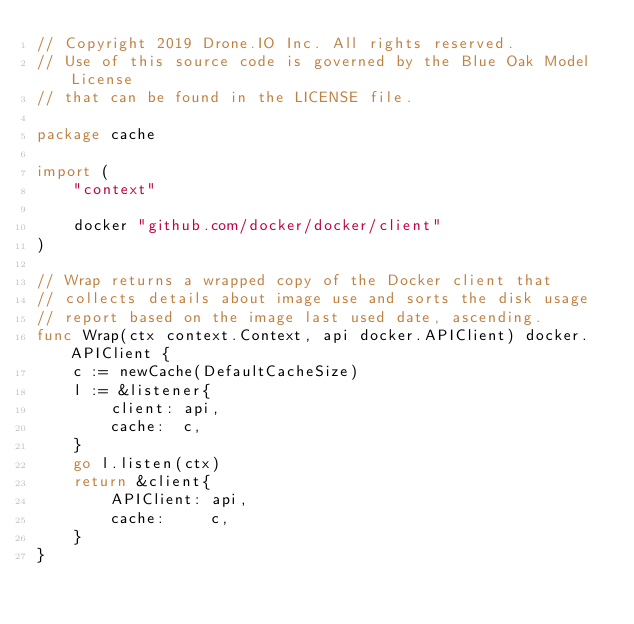Convert code to text. <code><loc_0><loc_0><loc_500><loc_500><_Go_>// Copyright 2019 Drone.IO Inc. All rights reserved.
// Use of this source code is governed by the Blue Oak Model License
// that can be found in the LICENSE file.

package cache

import (
	"context"

	docker "github.com/docker/docker/client"
)

// Wrap returns a wrapped copy of the Docker client that
// collects details about image use and sorts the disk usage
// report based on the image last used date, ascending.
func Wrap(ctx context.Context, api docker.APIClient) docker.APIClient {
	c := newCache(DefaultCacheSize)
	l := &listener{
		client: api,
		cache:  c,
	}
	go l.listen(ctx)
	return &client{
		APIClient: api,
		cache:     c,
	}
}
</code> 